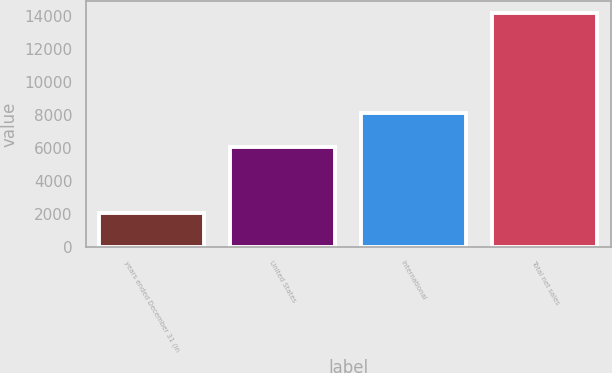Convert chart to OTSL. <chart><loc_0><loc_0><loc_500><loc_500><bar_chart><fcel>years ended December 31 (in<fcel>United States<fcel>International<fcel>Total net sales<nl><fcel>2012<fcel>6056<fcel>8134<fcel>14190<nl></chart> 